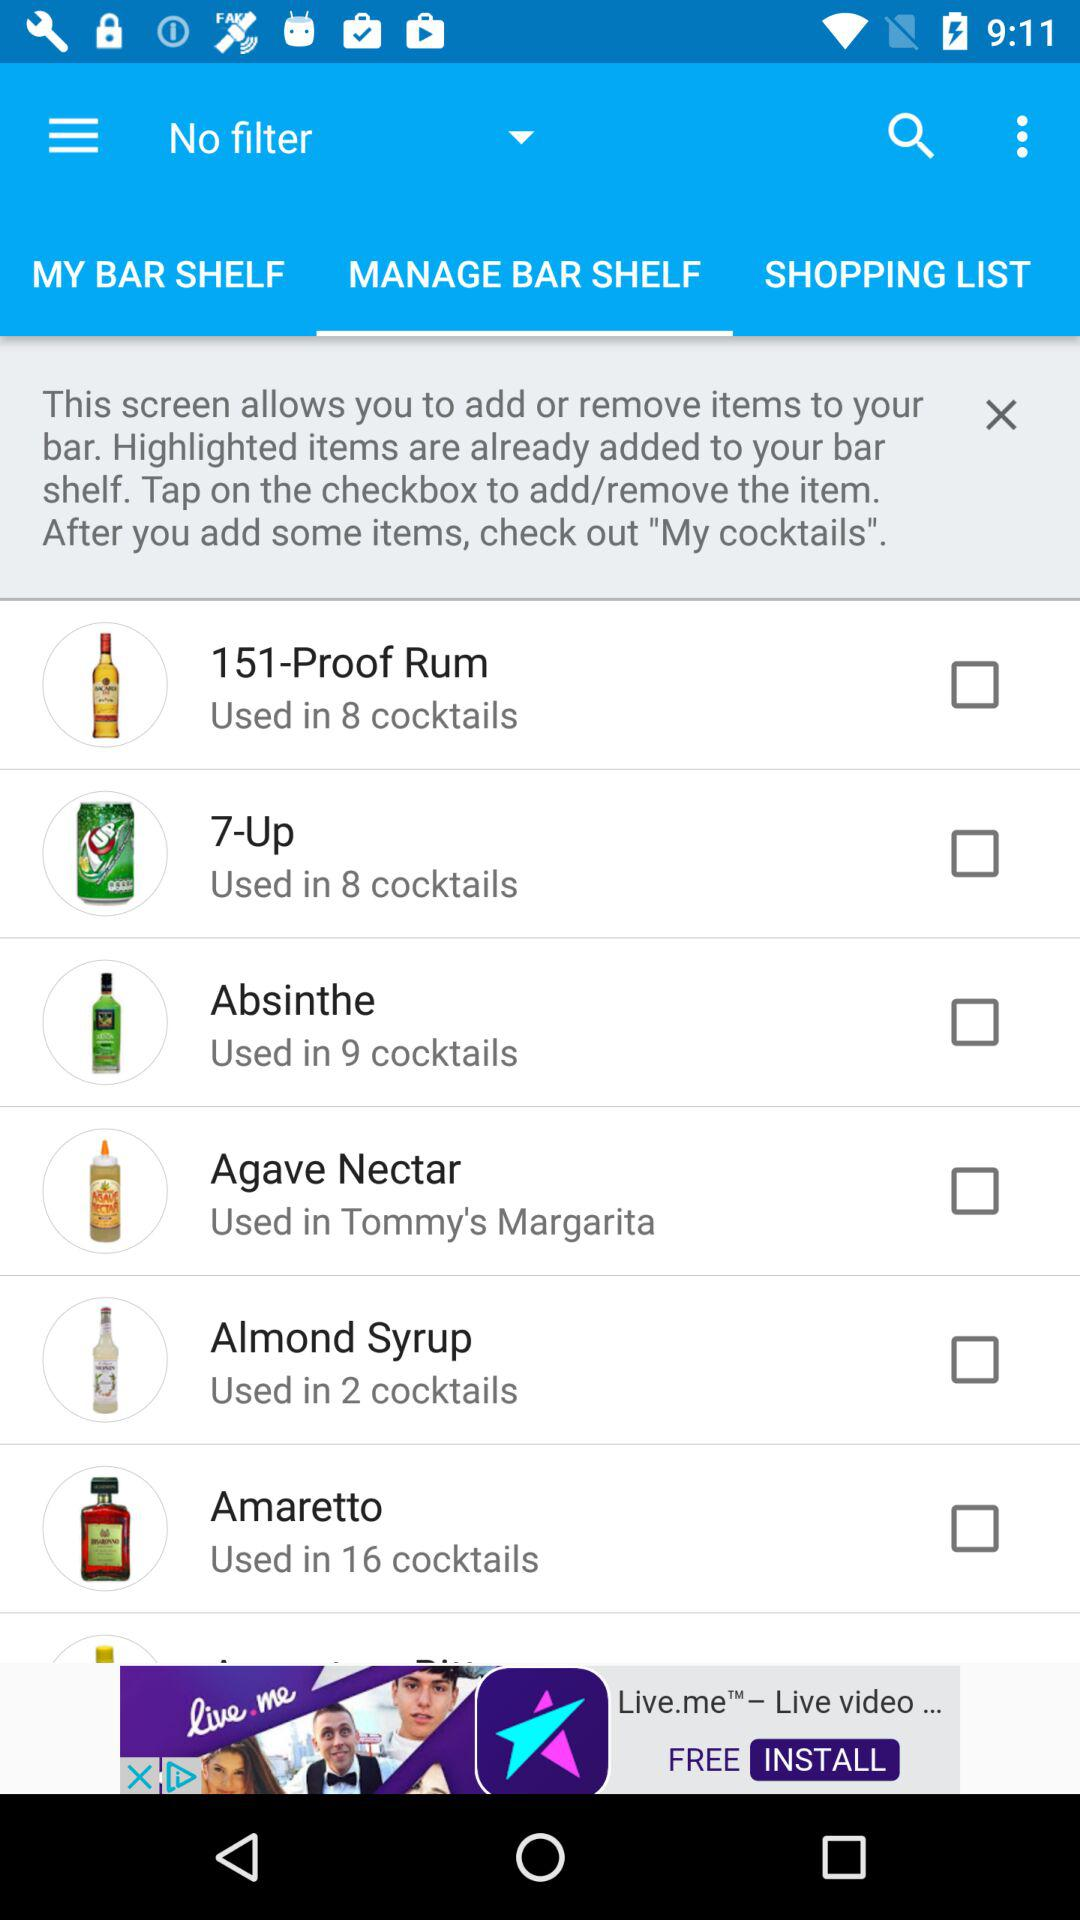Which tab is currently selected? Currently, the selected tab is "MANAGE BAR SHELF". 